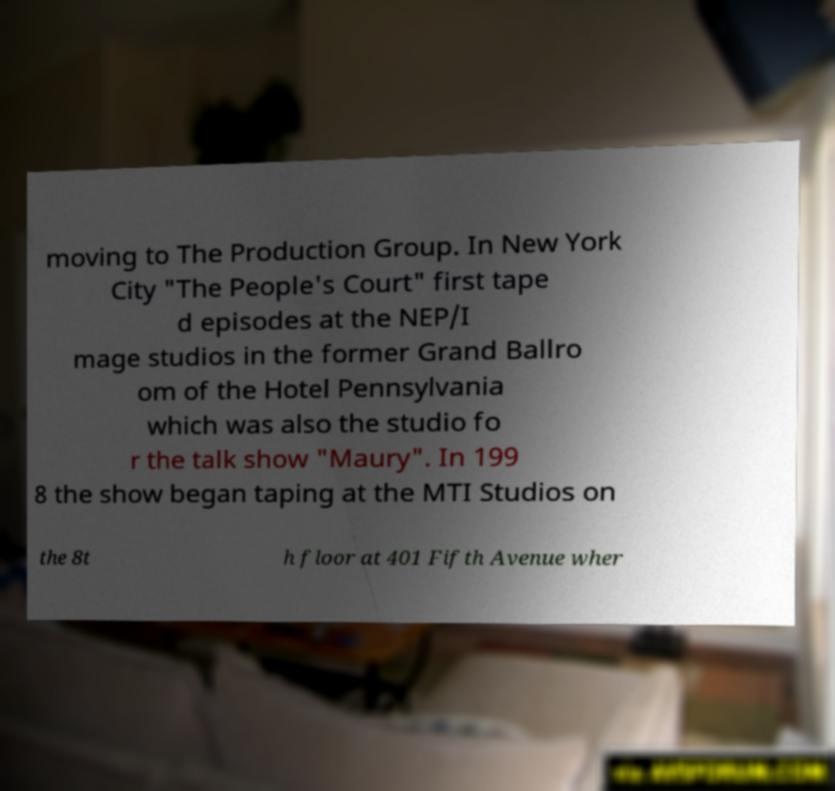Could you assist in decoding the text presented in this image and type it out clearly? moving to The Production Group. In New York City "The People's Court" first tape d episodes at the NEP/I mage studios in the former Grand Ballro om of the Hotel Pennsylvania which was also the studio fo r the talk show "Maury". In 199 8 the show began taping at the MTI Studios on the 8t h floor at 401 Fifth Avenue wher 